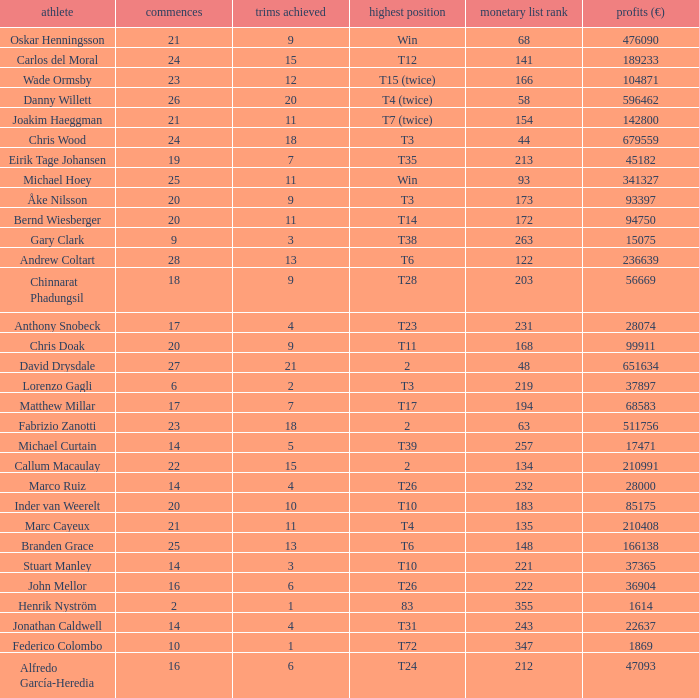How many cuts did the player who earned 210408 Euro make? 11.0. 